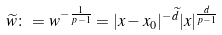<formula> <loc_0><loc_0><loc_500><loc_500>\widetilde { w } \colon = w ^ { - \frac { 1 } { p - 1 } } = | x - x _ { 0 } | ^ { - \widetilde { d } } | x | ^ { \frac { d } { p - 1 } }</formula> 